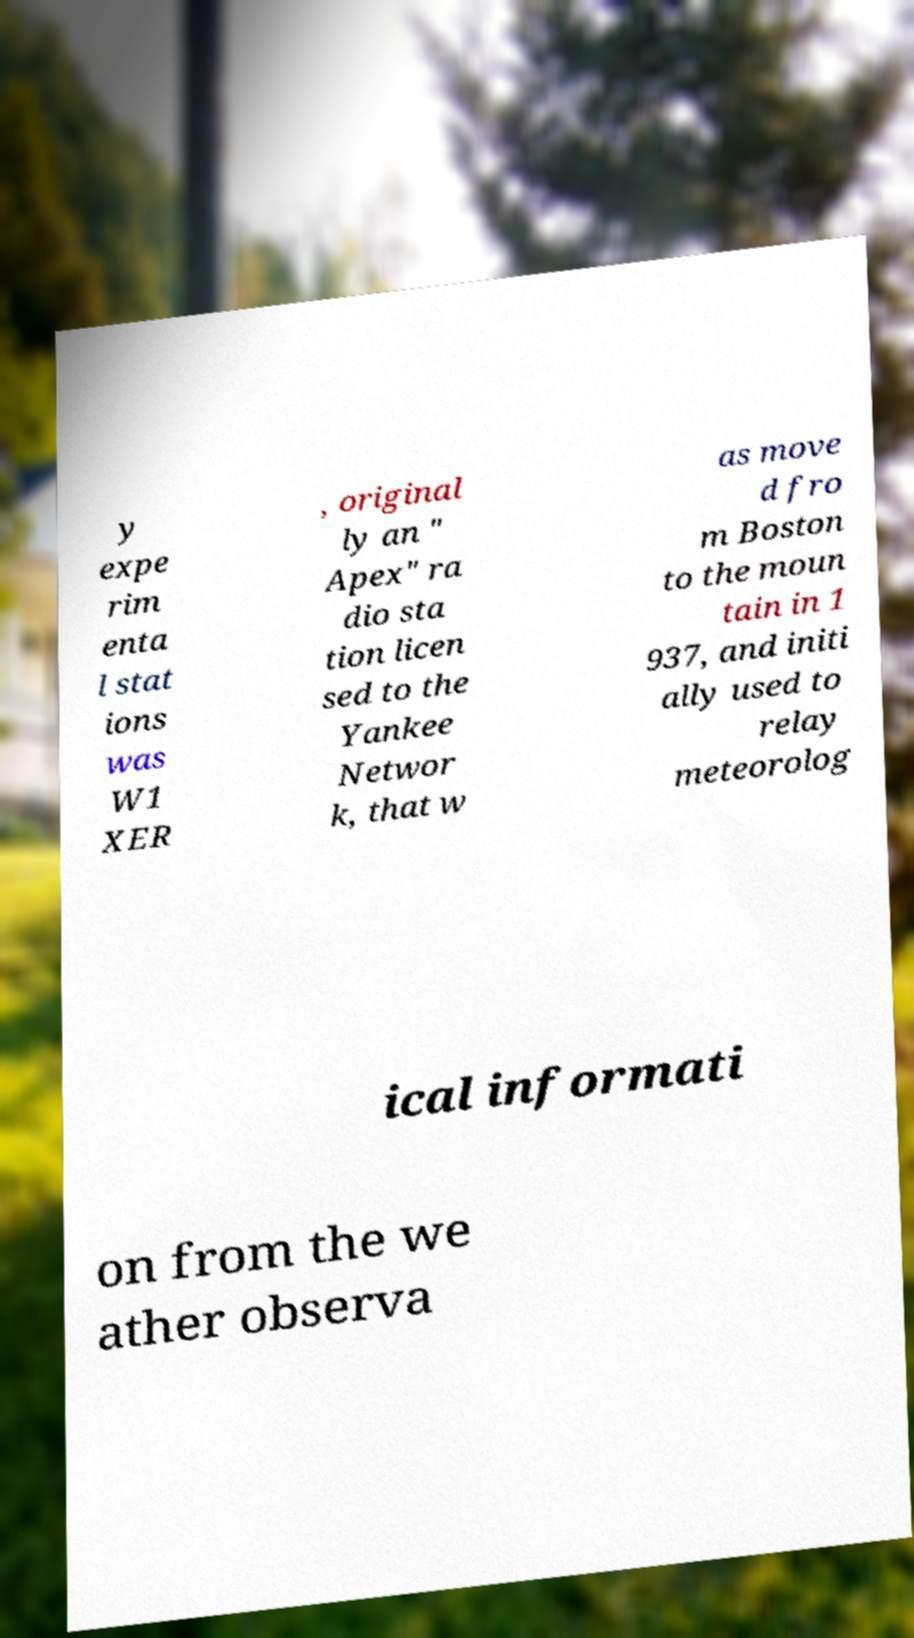Could you extract and type out the text from this image? y expe rim enta l stat ions was W1 XER , original ly an " Apex" ra dio sta tion licen sed to the Yankee Networ k, that w as move d fro m Boston to the moun tain in 1 937, and initi ally used to relay meteorolog ical informati on from the we ather observa 